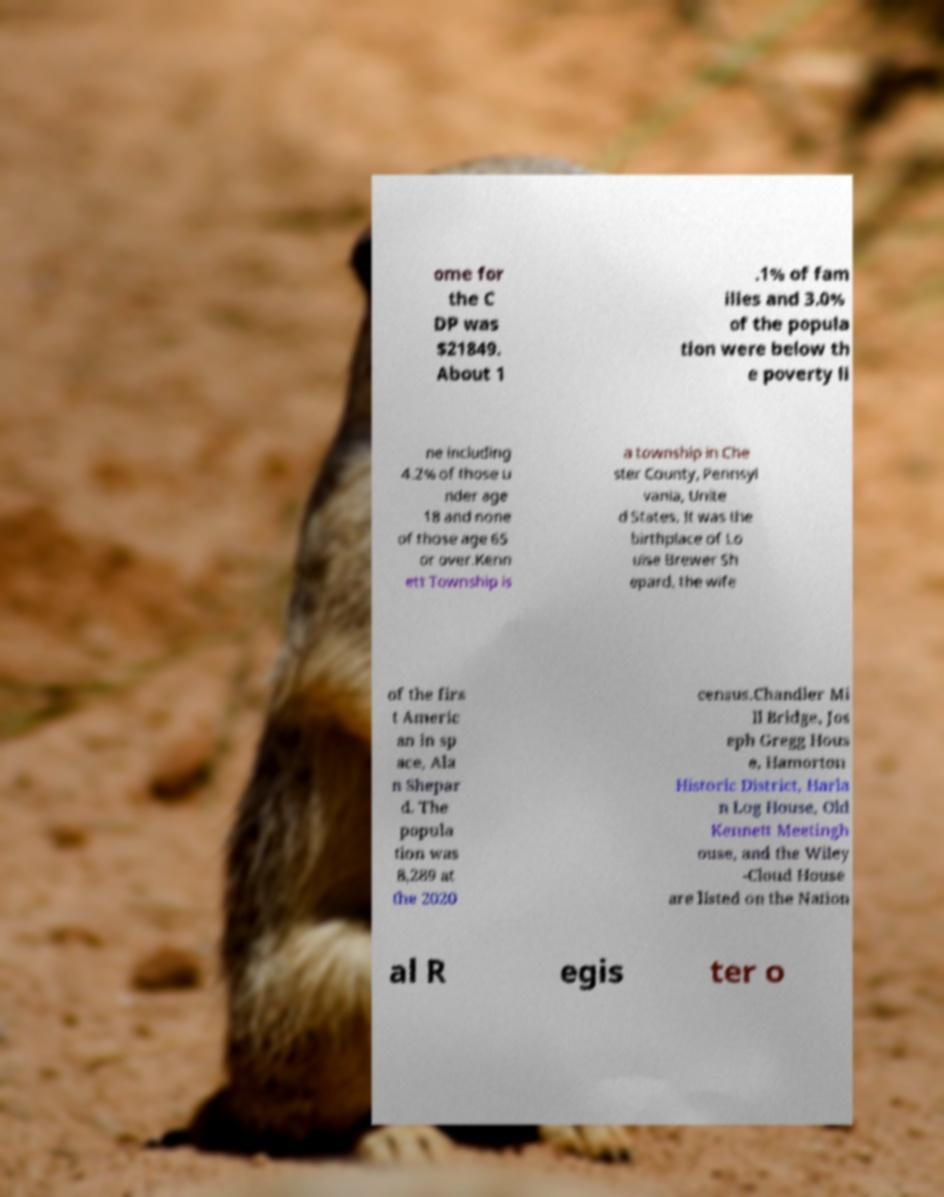Could you extract and type out the text from this image? ome for the C DP was $21849. About 1 .1% of fam ilies and 3.0% of the popula tion were below th e poverty li ne including 4.2% of those u nder age 18 and none of those age 65 or over.Kenn ett Township is a township in Che ster County, Pennsyl vania, Unite d States. It was the birthplace of Lo uise Brewer Sh epard, the wife of the firs t Americ an in sp ace, Ala n Shepar d. The popula tion was 8,289 at the 2020 census.Chandler Mi ll Bridge, Jos eph Gregg Hous e, Hamorton Historic District, Harla n Log House, Old Kennett Meetingh ouse, and the Wiley -Cloud House are listed on the Nation al R egis ter o 